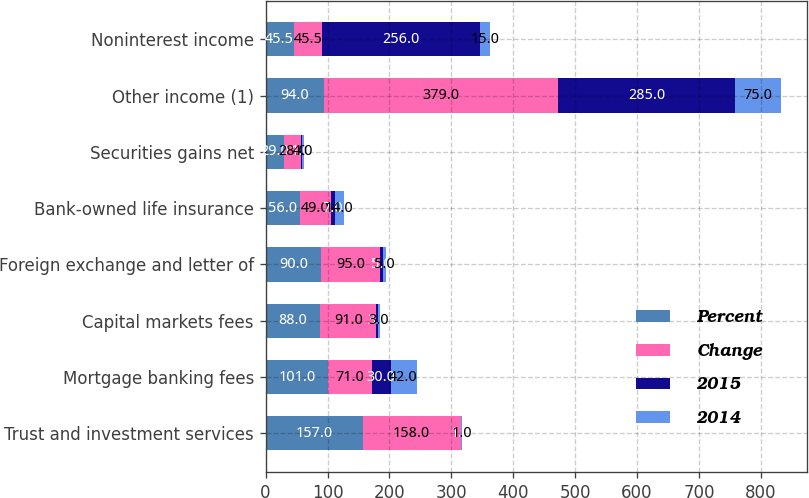Convert chart. <chart><loc_0><loc_0><loc_500><loc_500><stacked_bar_chart><ecel><fcel>Trust and investment services<fcel>Mortgage banking fees<fcel>Capital markets fees<fcel>Foreign exchange and letter of<fcel>Bank-owned life insurance<fcel>Securities gains net<fcel>Other income (1)<fcel>Noninterest income<nl><fcel>Percent<fcel>157<fcel>101<fcel>88<fcel>90<fcel>56<fcel>29<fcel>94<fcel>45.5<nl><fcel>Change<fcel>158<fcel>71<fcel>91<fcel>95<fcel>49<fcel>28<fcel>379<fcel>45.5<nl><fcel>2015<fcel>1<fcel>30<fcel>3<fcel>5<fcel>7<fcel>1<fcel>285<fcel>256<nl><fcel>2014<fcel>1<fcel>42<fcel>3<fcel>5<fcel>14<fcel>4<fcel>75<fcel>15<nl></chart> 